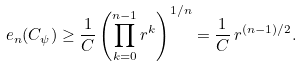Convert formula to latex. <formula><loc_0><loc_0><loc_500><loc_500>e _ { n } ( C _ { \psi } ) \geq \frac { 1 } { C } \left ( \prod _ { k = 0 } ^ { n - 1 } r ^ { k } \right ) ^ { 1 / n } = \frac { 1 } { C } \, r ^ { ( n - 1 ) / 2 } .</formula> 